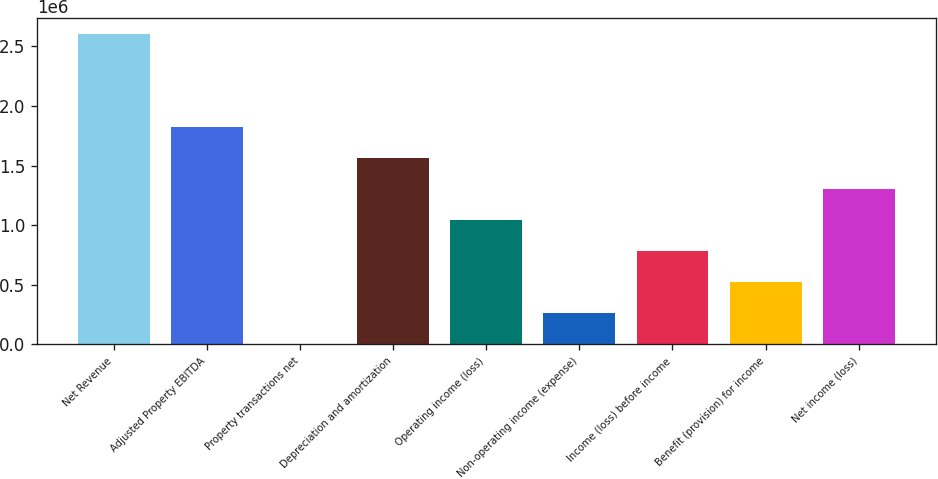Convert chart. <chart><loc_0><loc_0><loc_500><loc_500><bar_chart><fcel>Net Revenue<fcel>Adjusted Property EBITDA<fcel>Property transactions net<fcel>Depreciation and amortization<fcel>Operating income (loss)<fcel>Non-operating income (expense)<fcel>Income (loss) before income<fcel>Benefit (provision) for income<fcel>Net income (loss)<nl><fcel>2.60599e+06<fcel>1.82468e+06<fcel>1618<fcel>1.56424e+06<fcel>1.04337e+06<fcel>262056<fcel>782931<fcel>522493<fcel>1.30381e+06<nl></chart> 